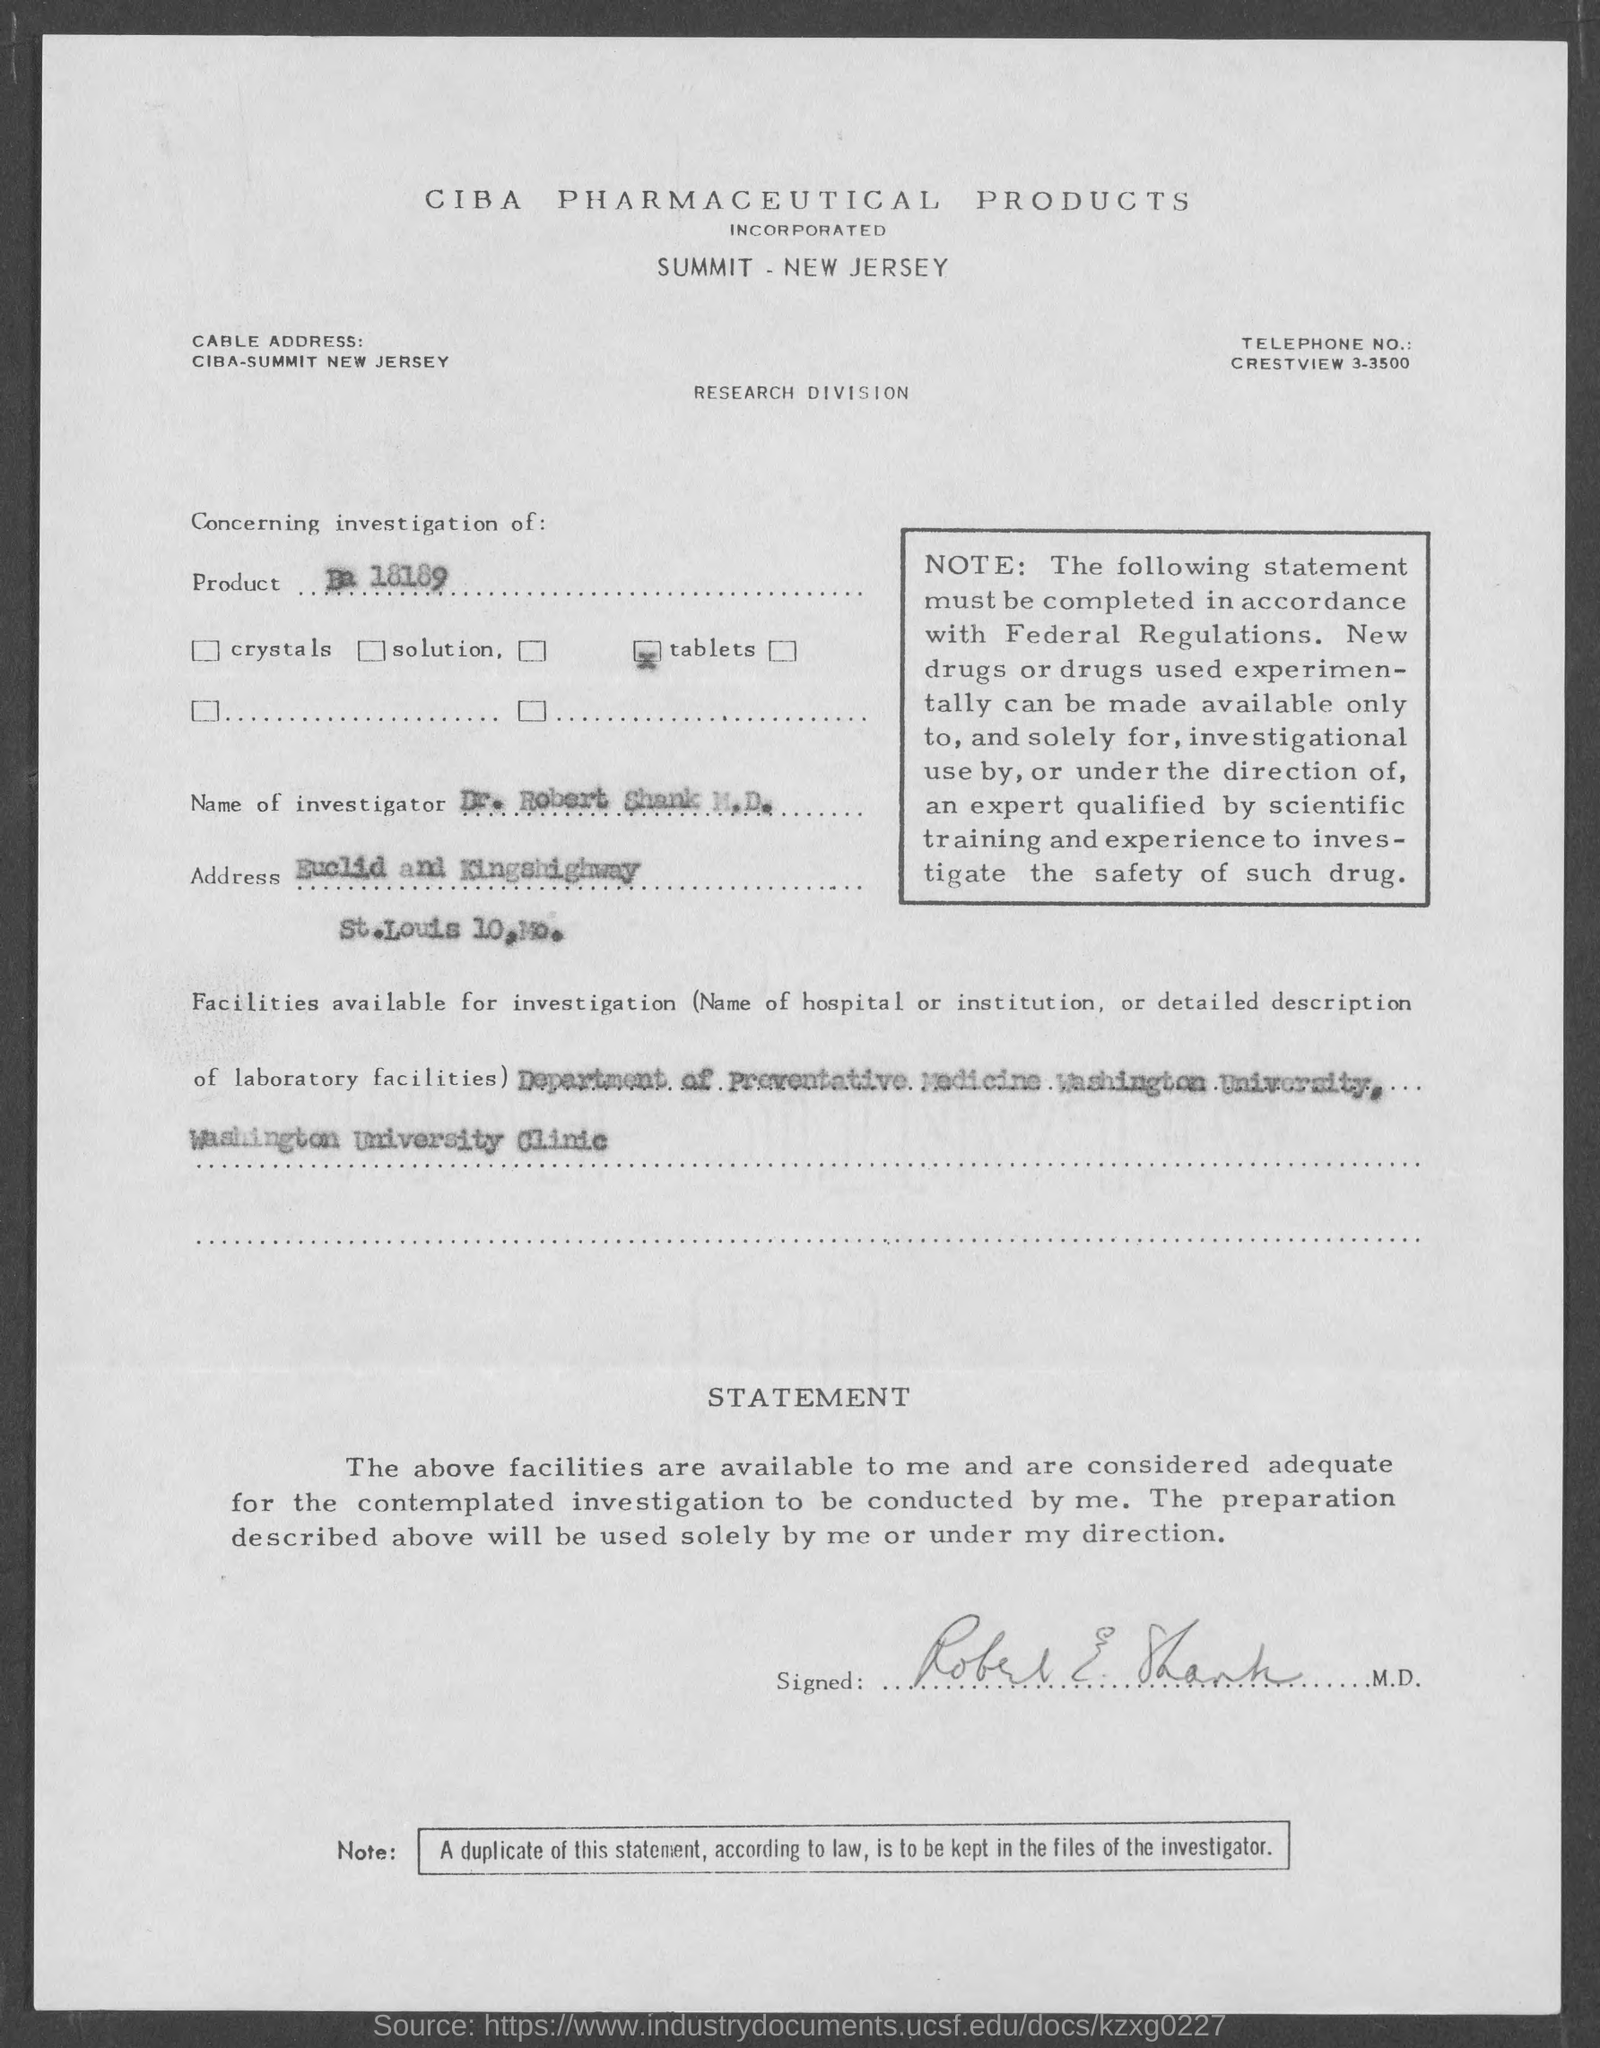Who has signed the statement?
Offer a terse response. Robert E. Shank. Which product is mentioned in the document?
Keep it short and to the point. Ba 18189. What is the name of the investigator given in the document?
Keep it short and to the point. Dr. Robert Shank M.D. Where are the facilities available for investigation?
Make the answer very short. Department of Preventive Medicine Washington University, Washington University Clinic. 